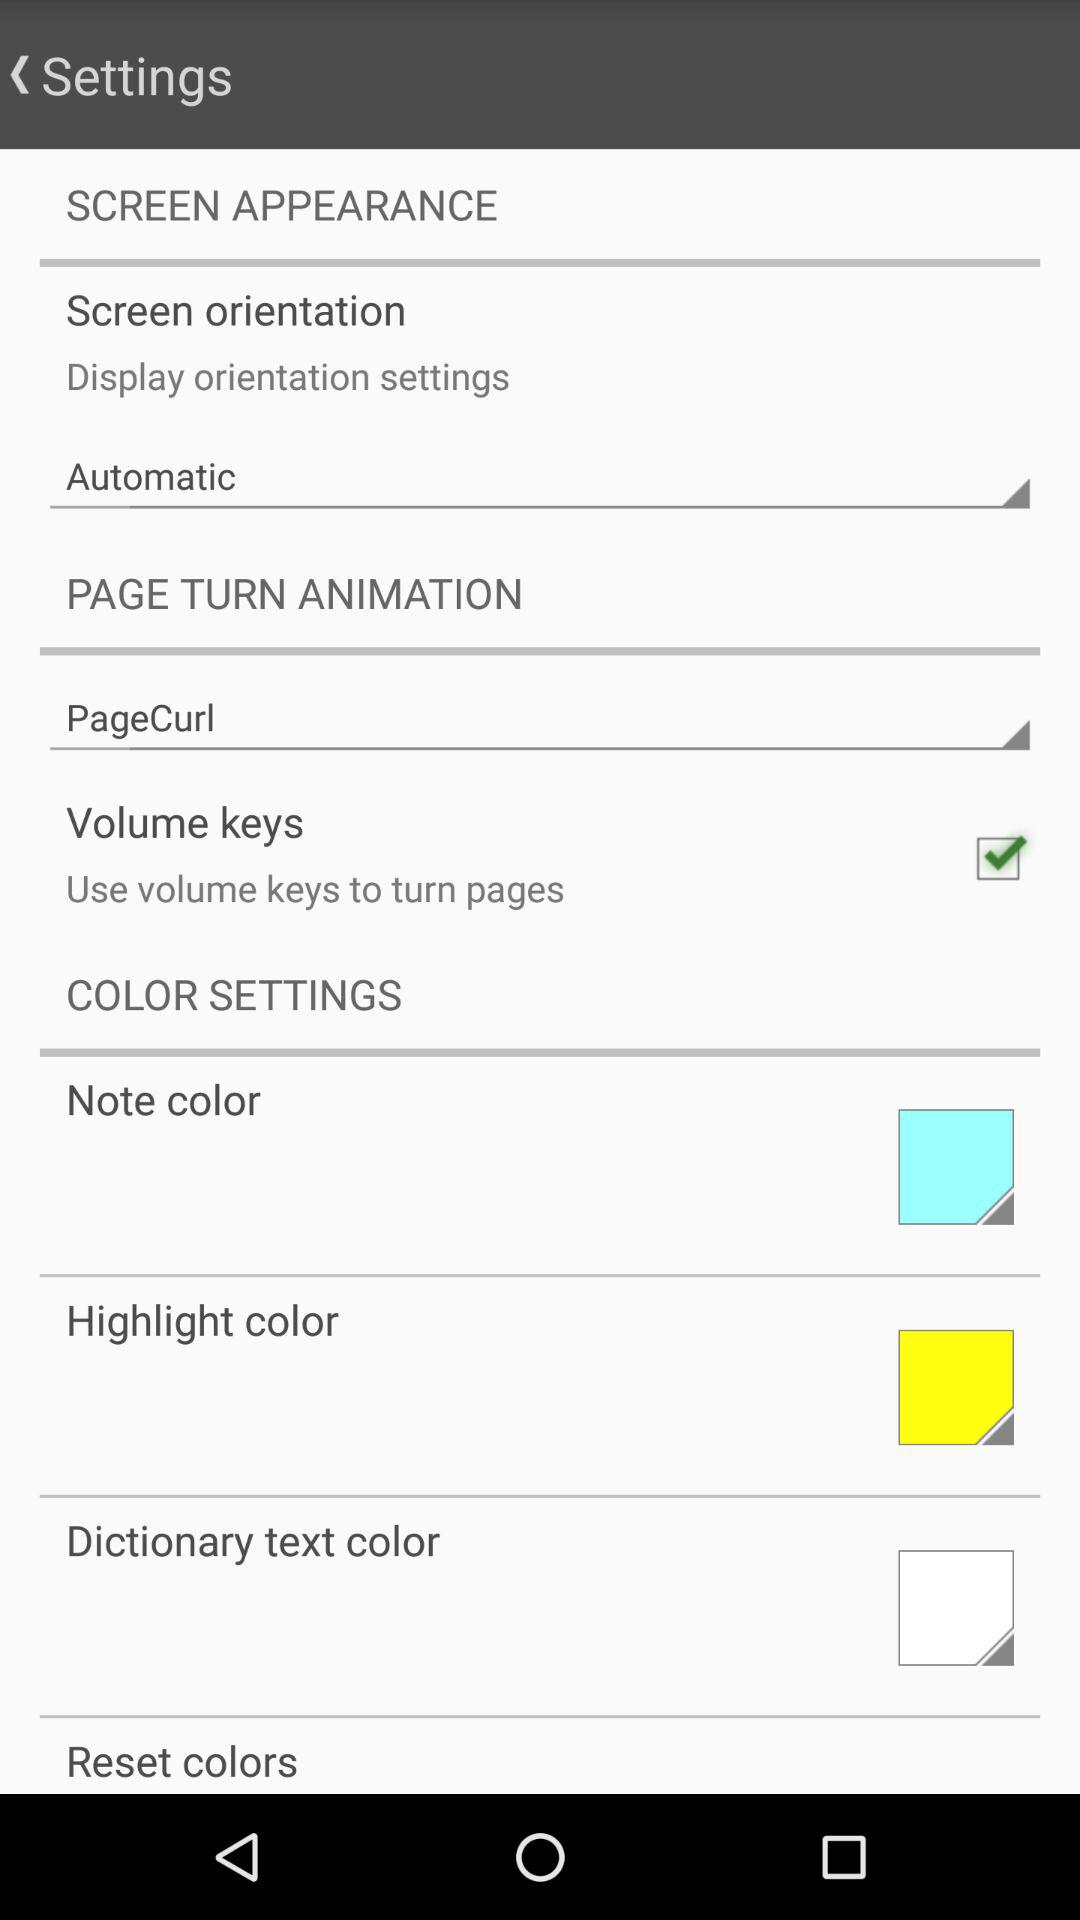What is the page turn animation? The page turn animation is "PageCurl". 